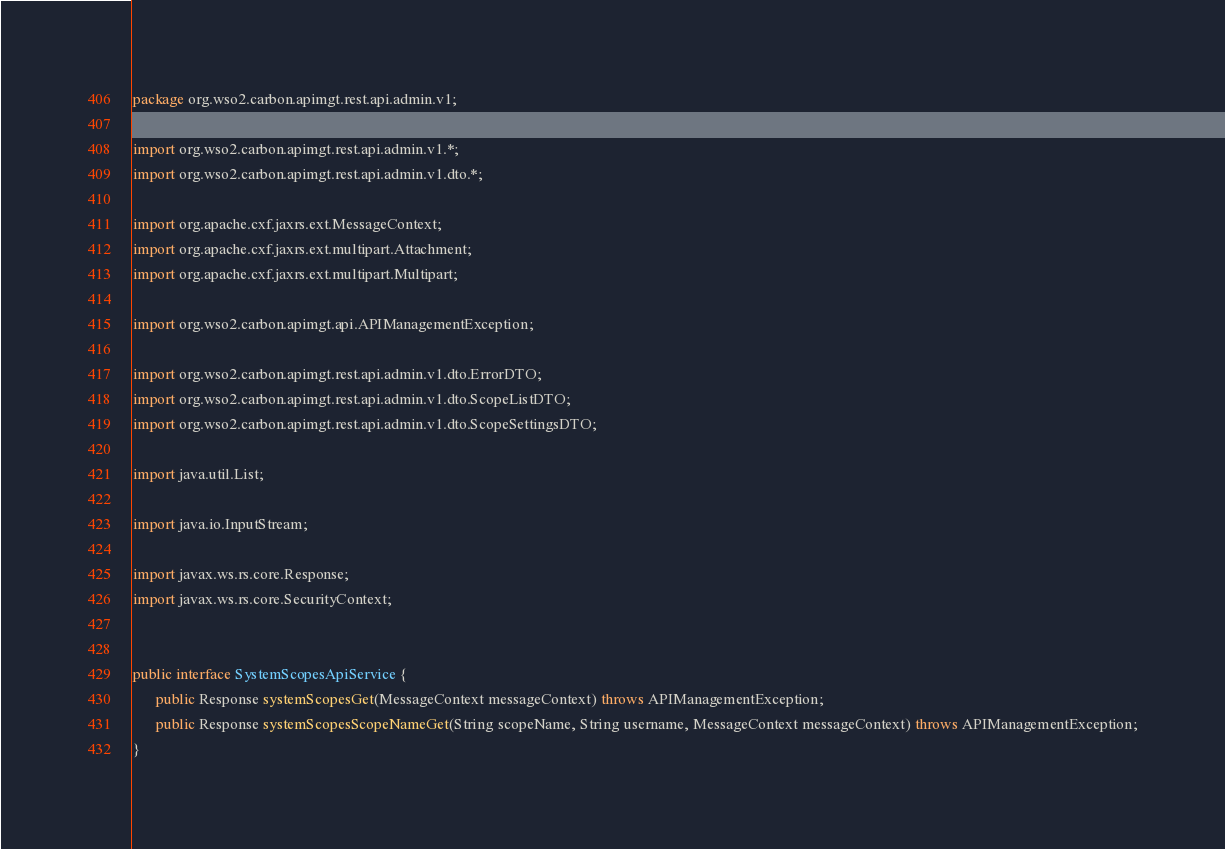Convert code to text. <code><loc_0><loc_0><loc_500><loc_500><_Java_>package org.wso2.carbon.apimgt.rest.api.admin.v1;

import org.wso2.carbon.apimgt.rest.api.admin.v1.*;
import org.wso2.carbon.apimgt.rest.api.admin.v1.dto.*;

import org.apache.cxf.jaxrs.ext.MessageContext;
import org.apache.cxf.jaxrs.ext.multipart.Attachment;
import org.apache.cxf.jaxrs.ext.multipart.Multipart;

import org.wso2.carbon.apimgt.api.APIManagementException;

import org.wso2.carbon.apimgt.rest.api.admin.v1.dto.ErrorDTO;
import org.wso2.carbon.apimgt.rest.api.admin.v1.dto.ScopeListDTO;
import org.wso2.carbon.apimgt.rest.api.admin.v1.dto.ScopeSettingsDTO;

import java.util.List;

import java.io.InputStream;

import javax.ws.rs.core.Response;
import javax.ws.rs.core.SecurityContext;


public interface SystemScopesApiService {
      public Response systemScopesGet(MessageContext messageContext) throws APIManagementException;
      public Response systemScopesScopeNameGet(String scopeName, String username, MessageContext messageContext) throws APIManagementException;
}
</code> 